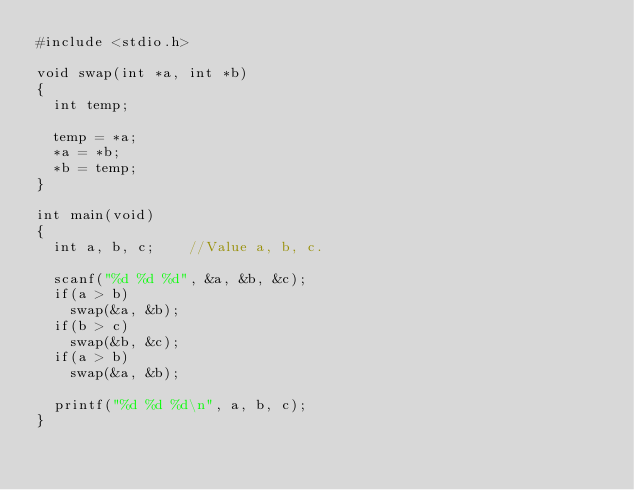<code> <loc_0><loc_0><loc_500><loc_500><_C_>#include <stdio.h>

void swap(int *a, int *b)
{
	int temp;

	temp = *a;
	*a = *b;
	*b = temp;
}

int main(void)
{
	int a, b, c;		//Value a, b, c.

	scanf("%d %d %d", &a, &b, &c);
	if(a > b)
		swap(&a, &b);
	if(b > c)
		swap(&b, &c);
	if(a > b)
		swap(&a, &b);

	printf("%d %d %d\n", a, b, c);
}

</code> 